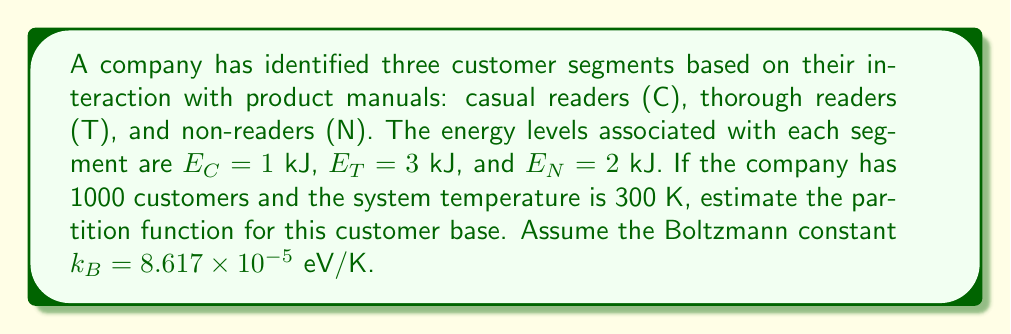Give your solution to this math problem. To estimate the partition function for the customer segments, we'll follow these steps:

1) The partition function Z is given by:
   $$Z = \sum_i g_i e^{-\beta E_i}$$
   where $g_i$ is the degeneracy of state i, $\beta = \frac{1}{k_B T}$, and $E_i$ is the energy of state i.

2) Convert temperature to eV:
   $$T = 300 \text{ K} \times 8.617 \times 10^{-5} \text{ eV/K} = 0.02585 \text{ eV}$$

3) Calculate $\beta$:
   $$\beta = \frac{1}{0.02585 \text{ eV}} = 38.68 \text{ eV}^{-1}$$

4) Convert energies to eV:
   $E_C = 1 \text{ kJ} = 6.242 \times 10^{15} \text{ eV}$
   $E_T = 3 \text{ kJ} = 1.873 \times 10^{16} \text{ eV}$
   $E_N = 2 \text{ kJ} = 1.248 \times 10^{16} \text{ eV}$

5) Calculate the exponents:
   $e^{-\beta E_C} = e^{-38.68 \times 6.242 \times 10^{15}} \approx 0$
   $e^{-\beta E_T} = e^{-38.68 \times 1.873 \times 10^{16}} \approx 0$
   $e^{-\beta E_N} = e^{-38.68 \times 1.248 \times 10^{16}} \approx 0$

6) The partition function is the sum of these terms:
   $$Z = g_C e^{-\beta E_C} + g_T e^{-\beta E_T} + g_N e^{-\beta E_N}$$

   Where $g_C + g_T + g_N = 1000$ (total number of customers)

7) Since all exponents are effectively zero, the partition function will also be approximately zero regardless of the distribution of customers among segments.
Answer: $Z \approx 0$ 